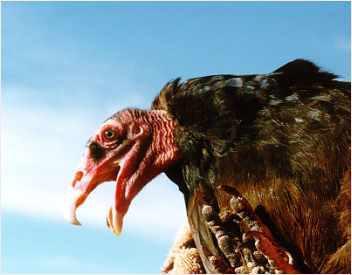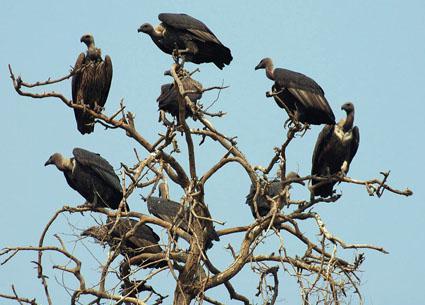The first image is the image on the left, the second image is the image on the right. Assess this claim about the two images: "One image contains more than four vultures on a tree that is at least mostly bare, and the other contains a single vulture.". Correct or not? Answer yes or no. Yes. The first image is the image on the left, the second image is the image on the right. Evaluate the accuracy of this statement regarding the images: "Each image includes a vulture with outspread wings, and one image contains a single vulture that is in mid-air.". Is it true? Answer yes or no. No. 